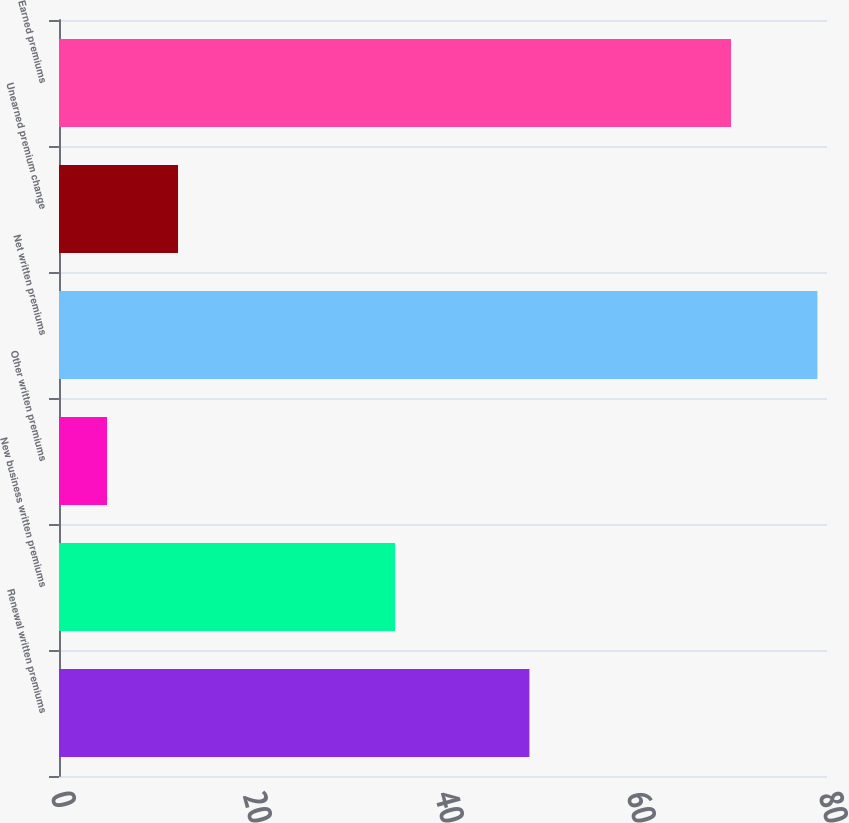Convert chart to OTSL. <chart><loc_0><loc_0><loc_500><loc_500><bar_chart><fcel>Renewal written premiums<fcel>New business written premiums<fcel>Other written premiums<fcel>Net written premiums<fcel>Unearned premium change<fcel>Earned premiums<nl><fcel>49<fcel>35<fcel>5<fcel>79<fcel>12.4<fcel>70<nl></chart> 